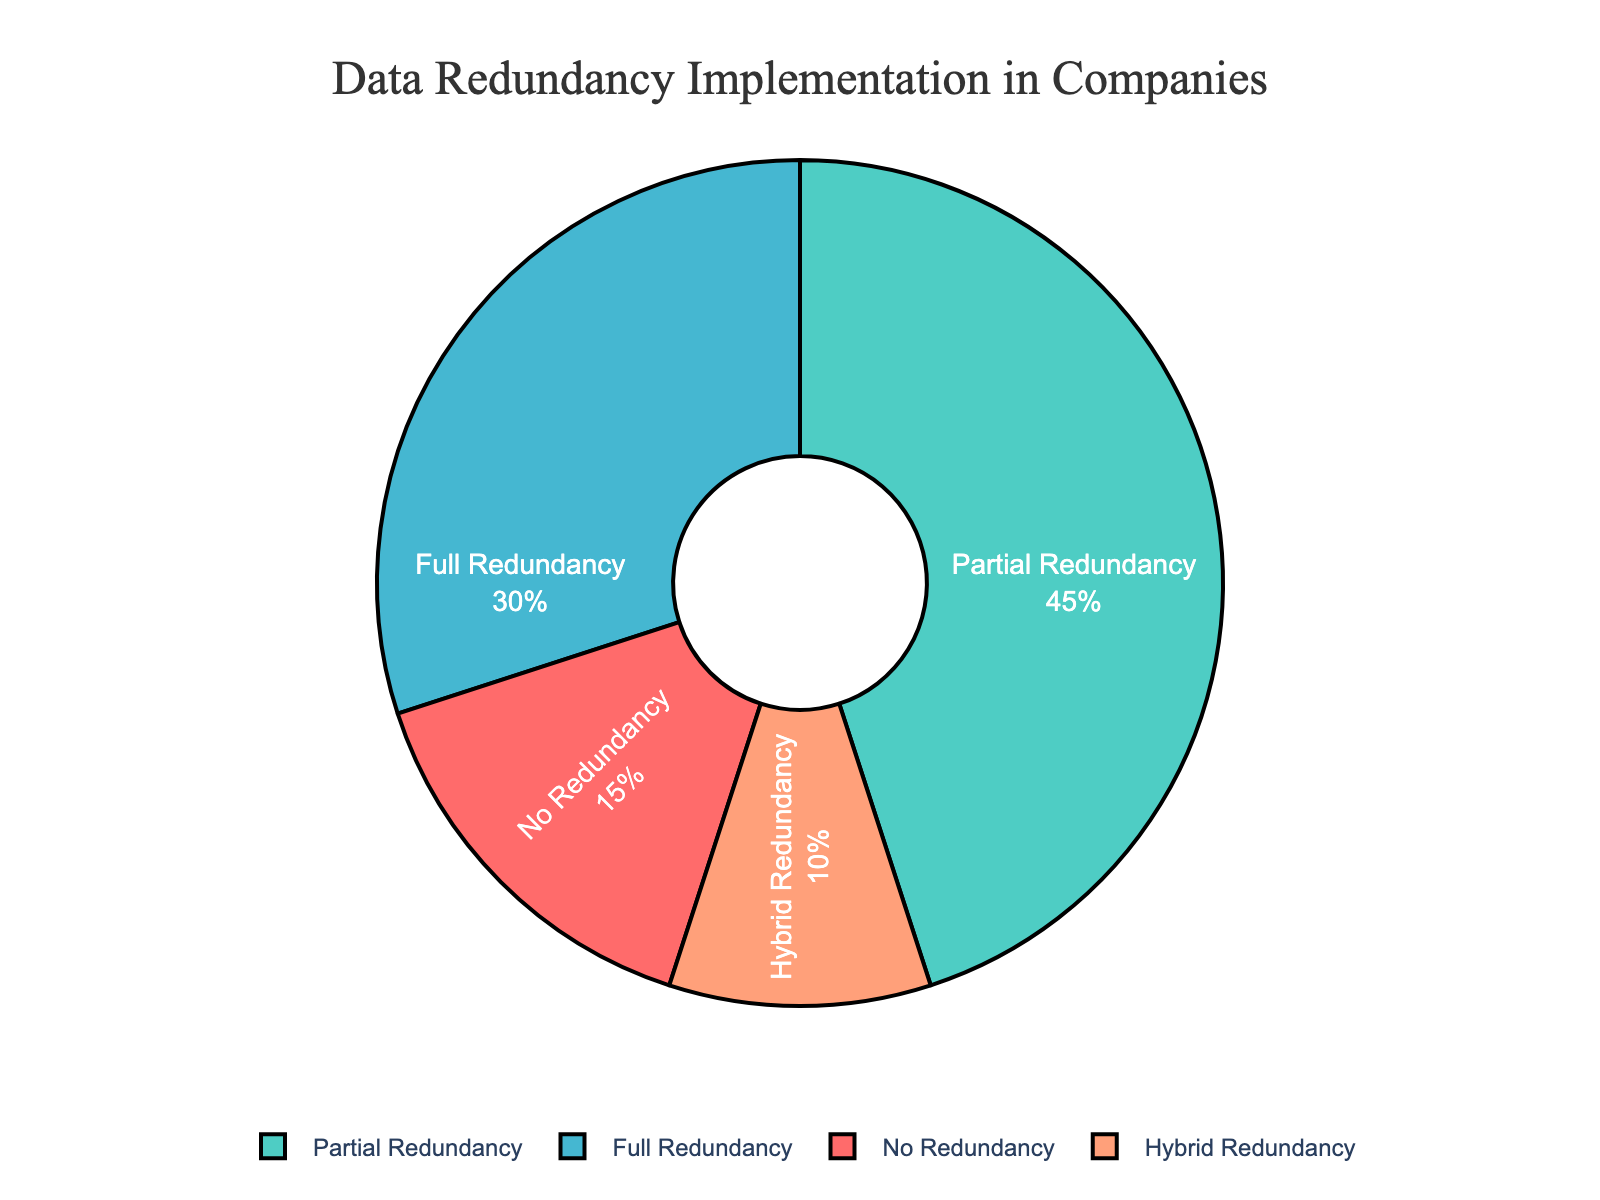What percentage of companies implement full data redundancy? To find this, look at the section of the pie chart labeled "Full Redundancy" and note its percentage.
Answer: 30% Is partial data redundancy implemented more frequently than no data redundancy? To determine this, compare the sections labeled "Partial Redundancy" and "No Redundancy" in the pie chart. Partial Redundancy has 45%, and No Redundancy has 15%.
Answer: Yes What is the total percentage of companies implementing either partial or full data redundancy? Add the percentage values for "Partial Redundancy" and "Full Redundancy" from the pie chart: 45% (Partial) + 30% (Full) = 75%.
Answer: 75% Which level of data redundancy is least used by companies? Identify the label with the smallest percentage in the pie chart. The "Hybrid Redundancy" section has the lowest percentage at 10%.
Answer: Hybrid Redundancy Does the combined percentage of companies with some form of data redundancy exceed 80%? First, sum the percentages for Partial Redundancy (45%), Full Redundancy (30%), and Hybrid Redundancy (10%), which amounts to 45% + 30% + 10% = 85%.
Answer: Yes How much greater is the percentage of companies with partial redundancy compared to hybrid redundancy? Subtract the percentage of "Hybrid Redundancy" from "Partial Redundancy": 45% - 10% = 35%.
Answer: 35% What's the combined percentage of companies not fully implementing data redundancy? Add the percentage values for "No Redundancy" and "Partial Redundancy": 15% (No) + 45% (Partial) = 60%.
Answer: 60% What color represents companies with no data redundancy? Look at the color filling the pie chart section labeled "No Redundancy."
Answer: Red Is the percentage of companies with no redundancy less than those with hybrid redundancy? Compare "No Redundancy" (15%) with "Hybrid Redundancy" (10%). No Redundancy is higher at 15%.
Answer: No Which data redundancy level is represented by the largest section of the pie chart? Identify the section with the biggest area. "Partial Redundancy" is the largest section at 45%.
Answer: Partial Redundancy 